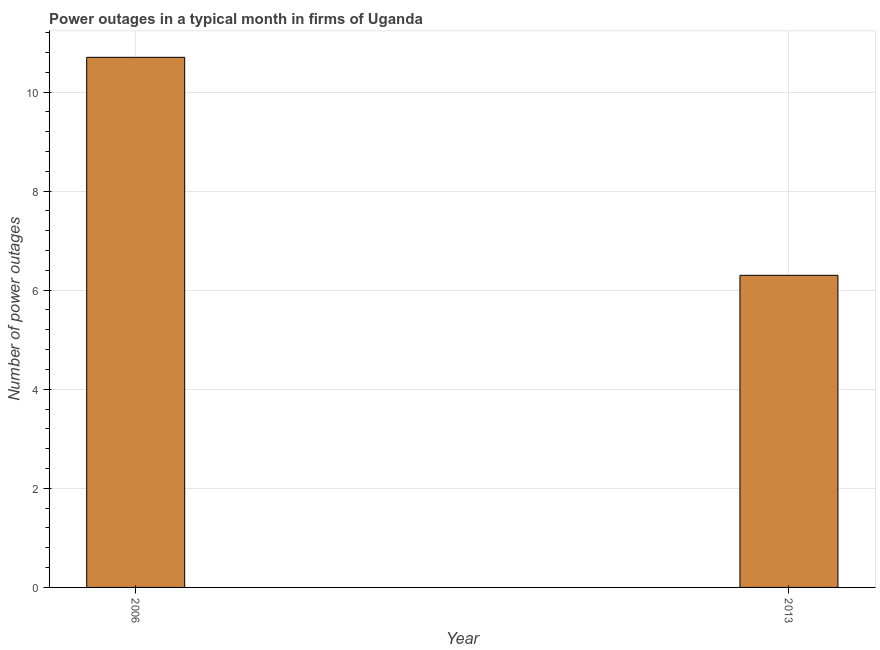Does the graph contain any zero values?
Ensure brevity in your answer.  No. Does the graph contain grids?
Ensure brevity in your answer.  Yes. What is the title of the graph?
Offer a terse response. Power outages in a typical month in firms of Uganda. What is the label or title of the Y-axis?
Keep it short and to the point. Number of power outages. What is the number of power outages in 2013?
Give a very brief answer. 6.3. What is the sum of the number of power outages?
Your answer should be very brief. 17. In how many years, is the number of power outages greater than 0.4 ?
Provide a short and direct response. 2. What is the ratio of the number of power outages in 2006 to that in 2013?
Provide a short and direct response. 1.7. Is the number of power outages in 2006 less than that in 2013?
Provide a short and direct response. No. In how many years, is the number of power outages greater than the average number of power outages taken over all years?
Provide a short and direct response. 1. How many bars are there?
Your answer should be very brief. 2. Are all the bars in the graph horizontal?
Provide a short and direct response. No. What is the difference between two consecutive major ticks on the Y-axis?
Give a very brief answer. 2. What is the Number of power outages of 2013?
Your response must be concise. 6.3. What is the ratio of the Number of power outages in 2006 to that in 2013?
Make the answer very short. 1.7. 